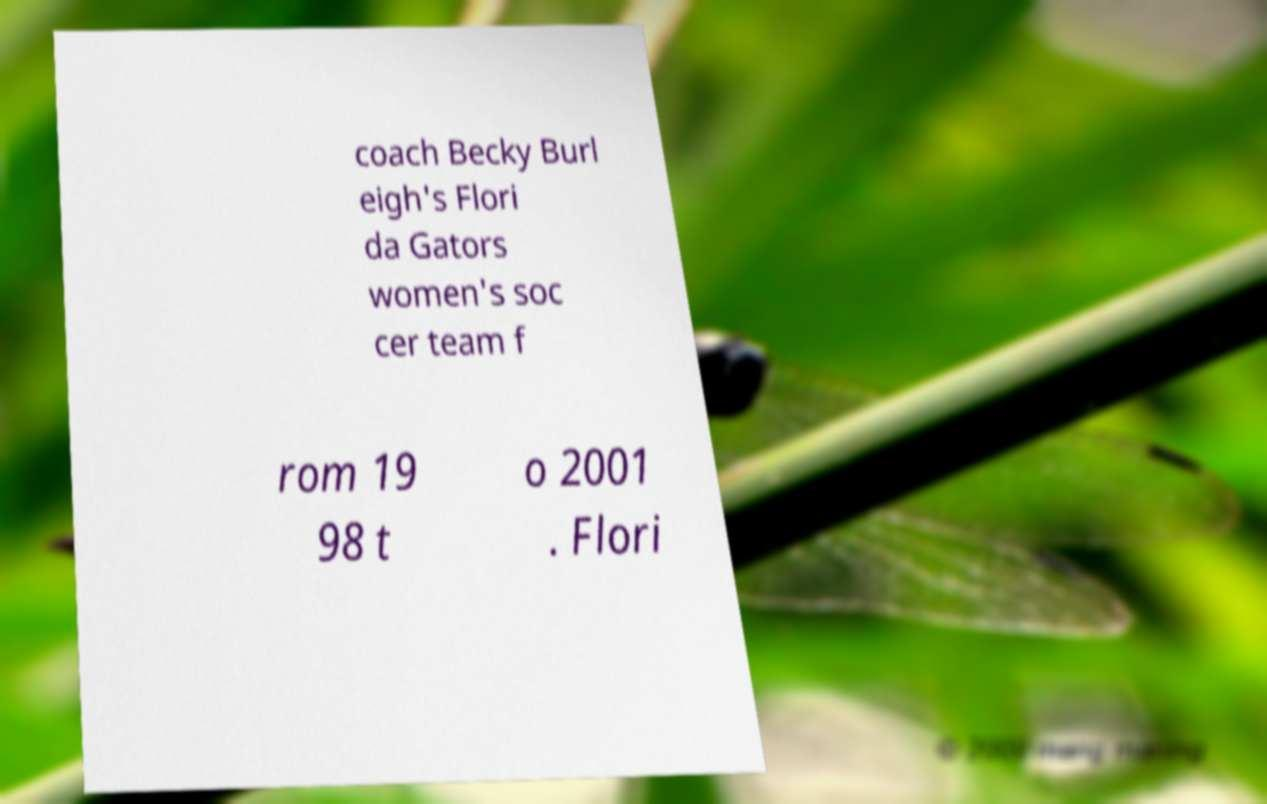There's text embedded in this image that I need extracted. Can you transcribe it verbatim? coach Becky Burl eigh's Flori da Gators women's soc cer team f rom 19 98 t o 2001 . Flori 